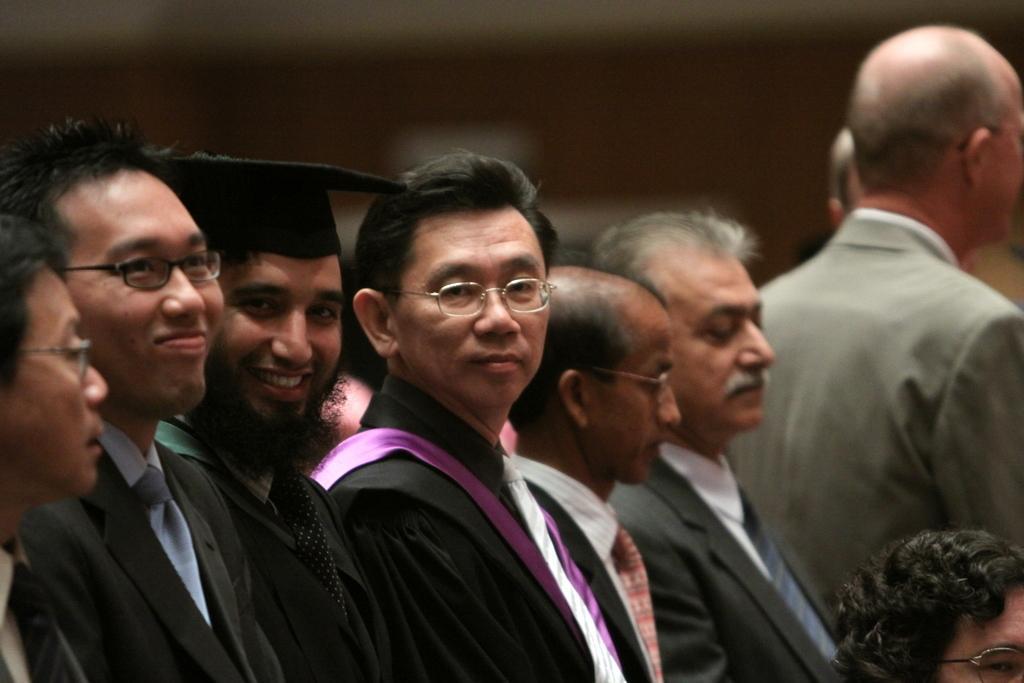Describe this image in one or two sentences. In this image I can see group of people standing. The person in front wearing black color dress and I can see blurred background. 